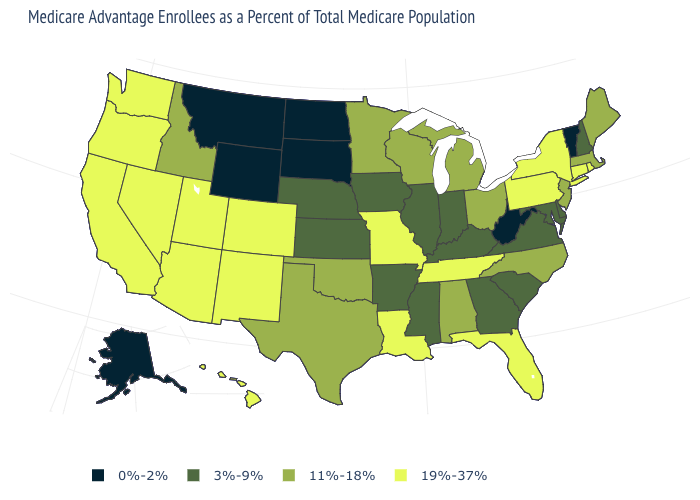What is the value of Nebraska?
Quick response, please. 3%-9%. How many symbols are there in the legend?
Answer briefly. 4. What is the lowest value in the USA?
Answer briefly. 0%-2%. How many symbols are there in the legend?
Keep it brief. 4. Which states have the lowest value in the South?
Be succinct. West Virginia. What is the value of Vermont?
Give a very brief answer. 0%-2%. Name the states that have a value in the range 11%-18%?
Answer briefly. Alabama, Idaho, Massachusetts, Maine, Michigan, Minnesota, North Carolina, New Jersey, Ohio, Oklahoma, Texas, Wisconsin. Does Colorado have a higher value than Delaware?
Be succinct. Yes. What is the value of Massachusetts?
Answer briefly. 11%-18%. What is the lowest value in the USA?
Keep it brief. 0%-2%. Does Montana have the highest value in the USA?
Keep it brief. No. Does New Mexico have the highest value in the West?
Concise answer only. Yes. Name the states that have a value in the range 11%-18%?
Concise answer only. Alabama, Idaho, Massachusetts, Maine, Michigan, Minnesota, North Carolina, New Jersey, Ohio, Oklahoma, Texas, Wisconsin. Which states have the highest value in the USA?
Quick response, please. Arizona, California, Colorado, Connecticut, Florida, Hawaii, Louisiana, Missouri, New Mexico, Nevada, New York, Oregon, Pennsylvania, Rhode Island, Tennessee, Utah, Washington. Does Arkansas have the lowest value in the South?
Answer briefly. No. 